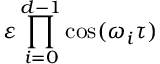Convert formula to latex. <formula><loc_0><loc_0><loc_500><loc_500>\varepsilon \prod _ { i = 0 } ^ { d - 1 } \cos ( \omega _ { i } \tau )</formula> 